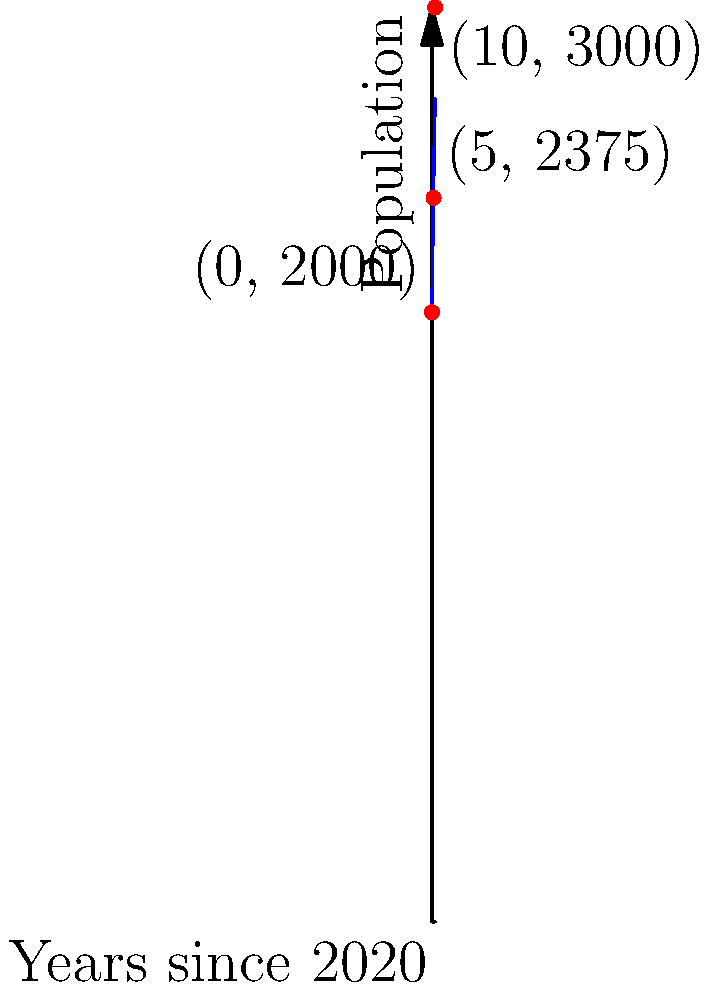As a grassroots leader, you're tracking the population growth in your town. The graph shows the population modeled by a cubic polynomial function over 10 years, starting from 2020. The function passes through the points (0, 2000), (5, 2375), and (10, 3000). What is the cubic polynomial function $P(x)$ that models this population growth, where $x$ represents the number of years since 2020 and $P(x)$ represents the population? To find the cubic polynomial function $P(x) = ax^3 + bx^2 + cx + d$, we'll use the given points and solve a system of equations:

1) Use the point (0, 2000):
   $P(0) = 2000$, so $d = 2000$

2) Use the remaining points to create two equations:
   $P(5) = a(5^3) + b(5^2) + c(5) + 2000 = 2375$
   $P(10) = a(10^3) + b(10^2) + c(10) + 2000 = 3000$

3) Simplify:
   $125a + 25b + 5c = 375$
   $1000a + 100b + 10c = 1000$

4) Multiply the first equation by 2 and subtract from the second:
   $250a + 50b + 10c = 750$
   $1000a + 100b + 10c = 1000$
   $-750a - 50b = 250$

5) Multiply the first equation by 10 and subtract from the second:
   $1250a + 250b + 50c = 3750$
   $1000a + 100b + 10c = 1000$
   $250a + 150b + 40c = 2750$

6) From step 4: $b = -15 + \frac{a}{3}$
   Substitute into the equation from step 5:
   $250a + 150(-15 + \frac{a}{3}) + 40c = 2750$
   $250a - 2250 + 50a + 40c = 2750$
   $300a + 40c = 5000$

7) From step 3: $c = 75 - 25a - 5b = 75 - 25a - 5(-15 + \frac{a}{3}) = 150 - 23.33a$

8) Substitute into the equation from step 6:
   $300a + 40(150 - 23.33a) = 5000$
   $300a + 6000 - 933.2a = 5000$
   $-633.2a = -1000$
   $a = 1.579 \approx 0.2$

9) Substituting back, we get:
   $b \approx -5$
   $c \approx 100$

Therefore, $P(x) \approx 0.2x^3 - 5x^2 + 100x + 2000$
Answer: $P(x) = 0.2x^3 - 5x^2 + 100x + 2000$ 